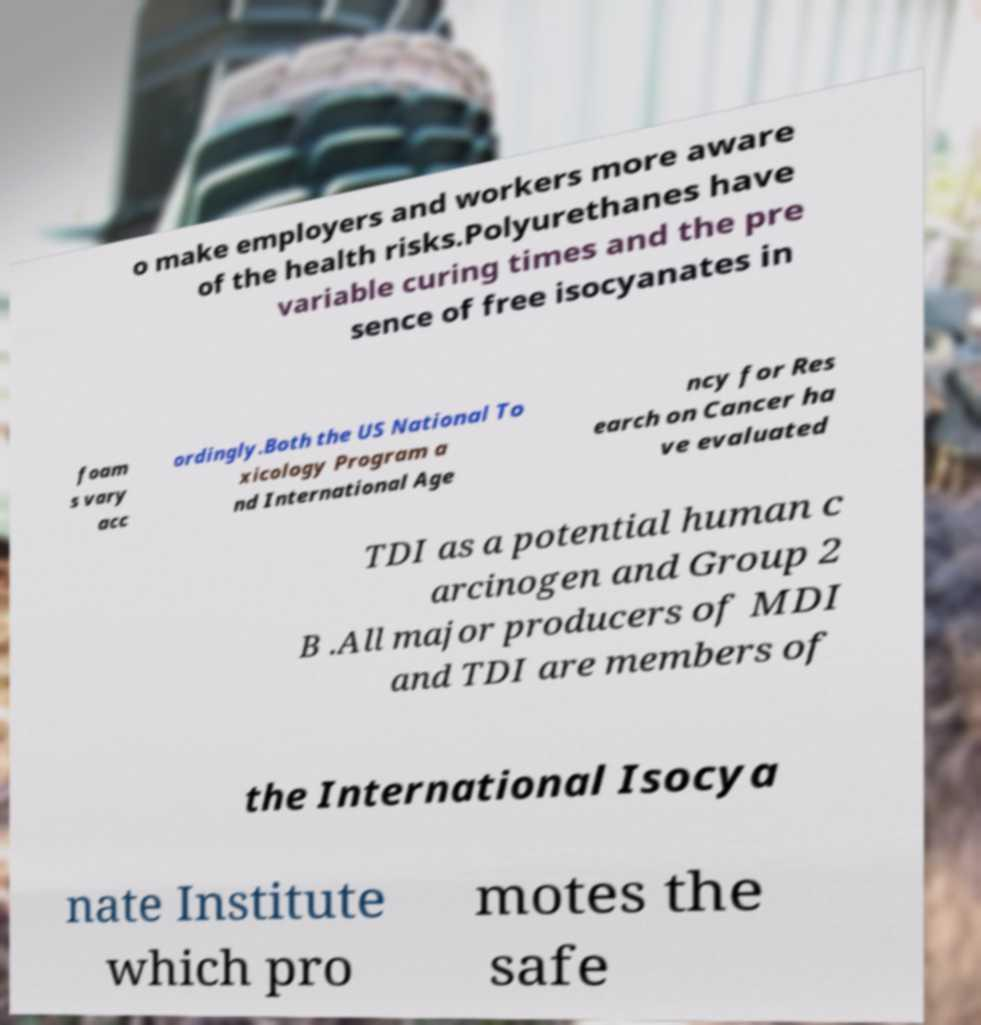Could you assist in decoding the text presented in this image and type it out clearly? o make employers and workers more aware of the health risks.Polyurethanes have variable curing times and the pre sence of free isocyanates in foam s vary acc ordingly.Both the US National To xicology Program a nd International Age ncy for Res earch on Cancer ha ve evaluated TDI as a potential human c arcinogen and Group 2 B .All major producers of MDI and TDI are members of the International Isocya nate Institute which pro motes the safe 